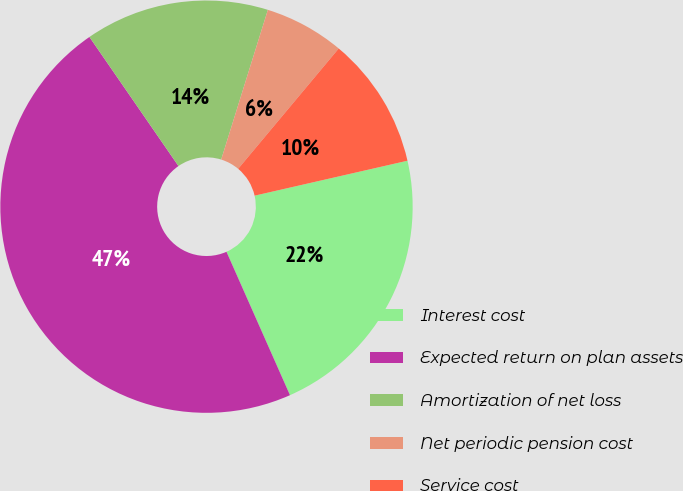<chart> <loc_0><loc_0><loc_500><loc_500><pie_chart><fcel>Interest cost<fcel>Expected return on plan assets<fcel>Amortization of net loss<fcel>Net periodic pension cost<fcel>Service cost<nl><fcel>21.94%<fcel>47.02%<fcel>14.42%<fcel>6.27%<fcel>10.34%<nl></chart> 